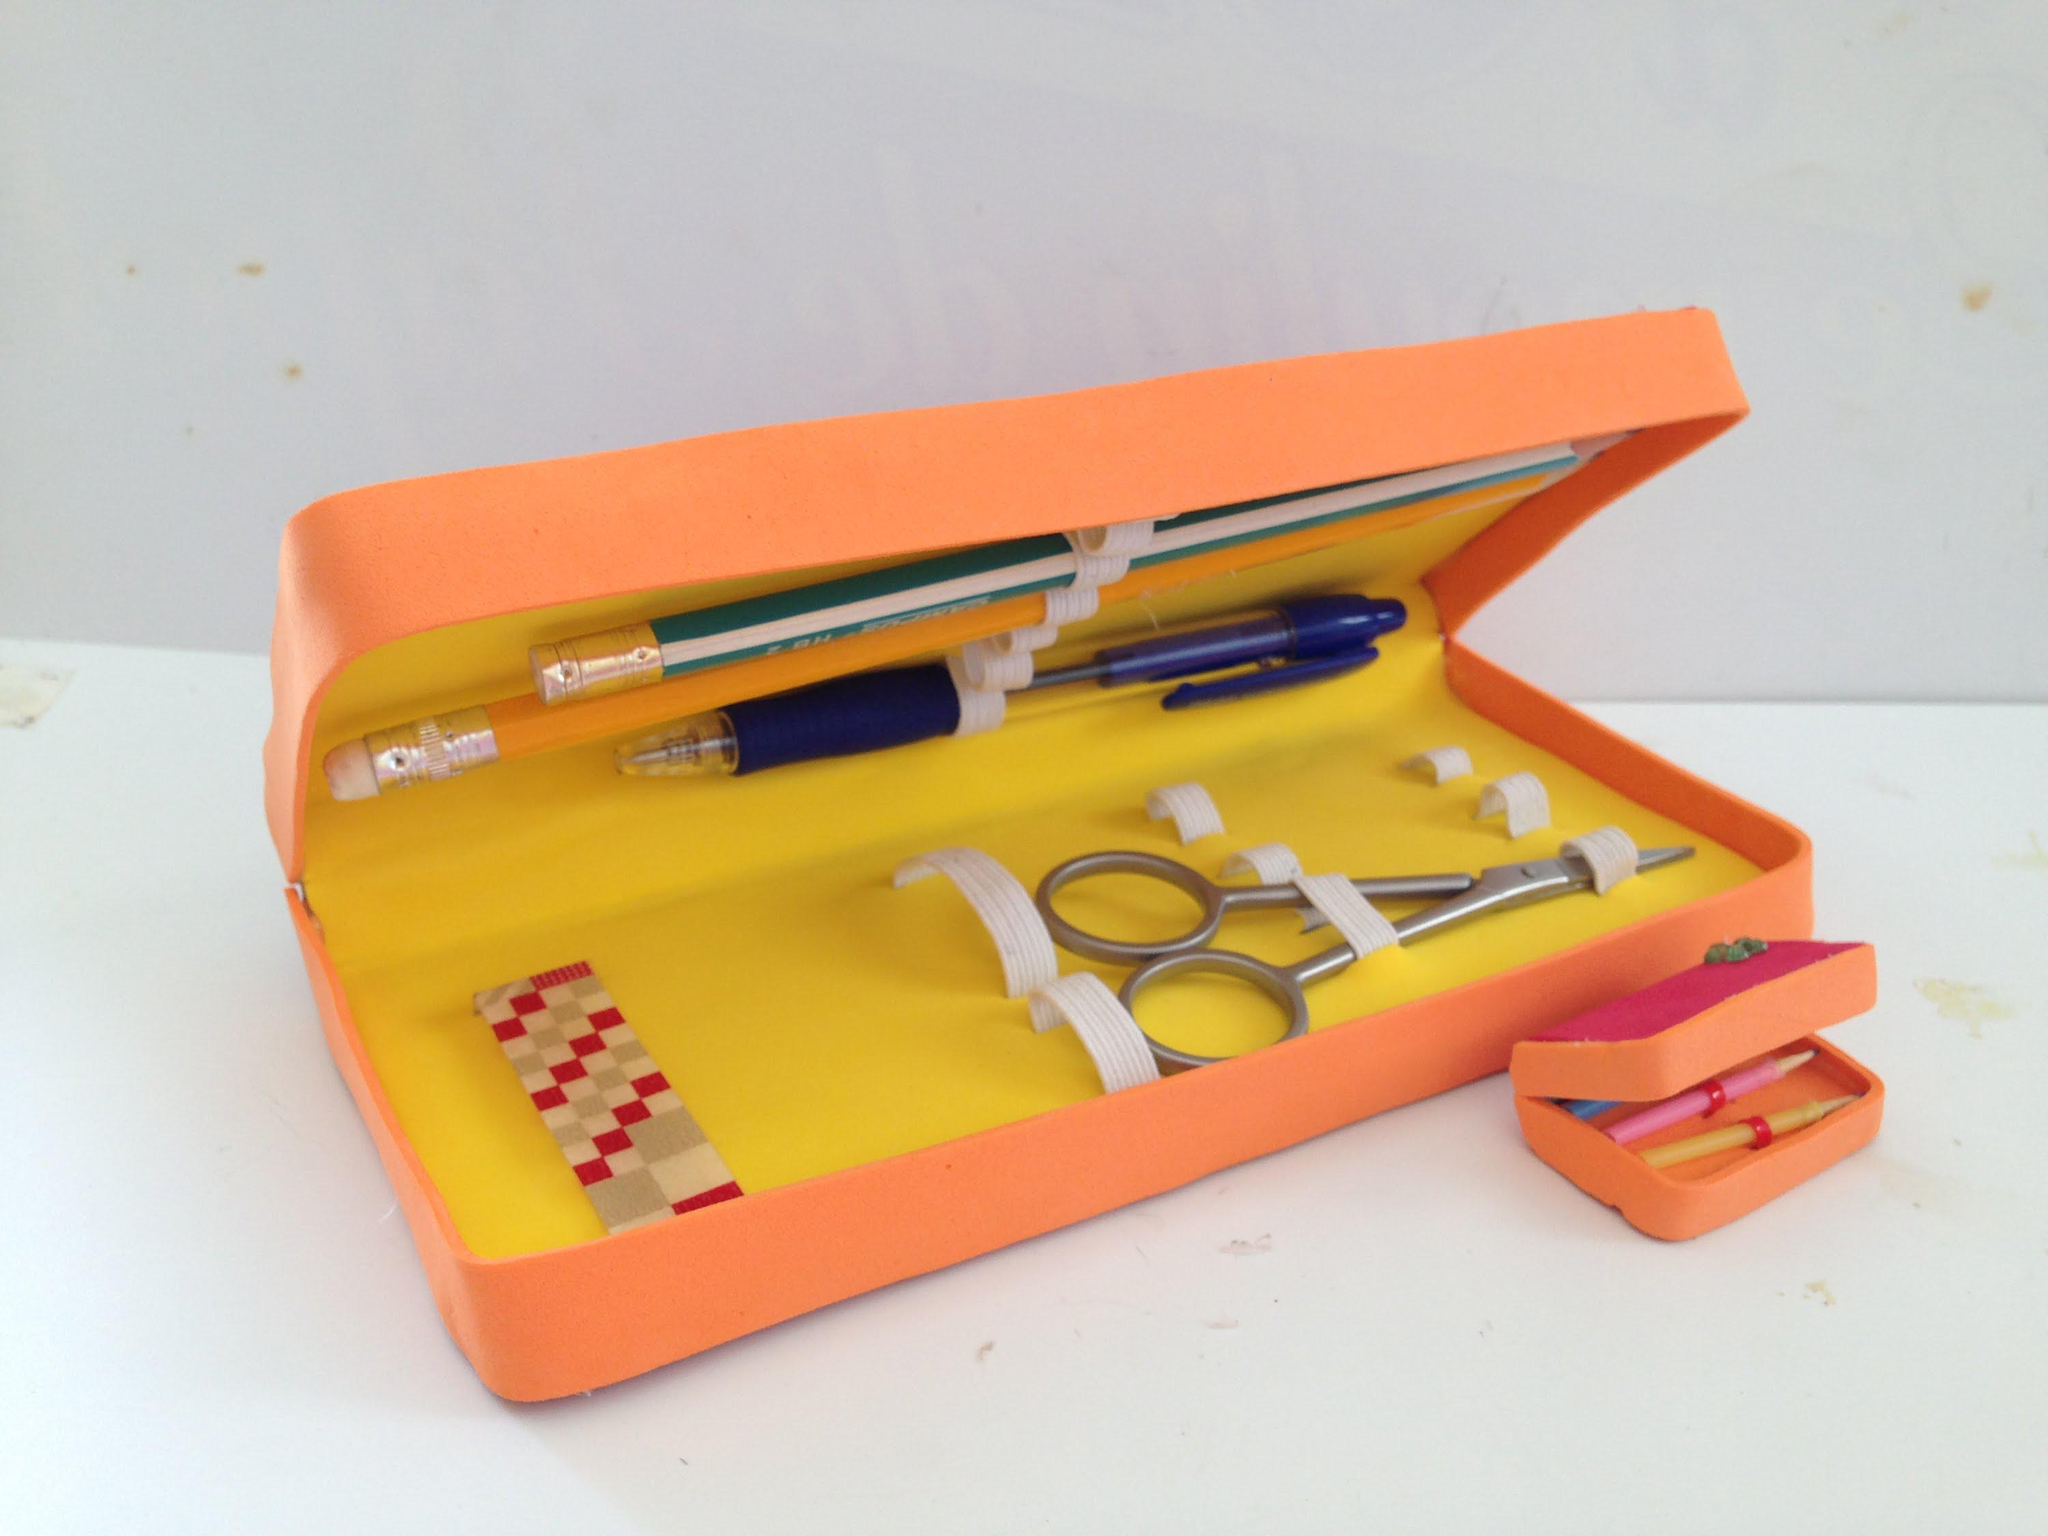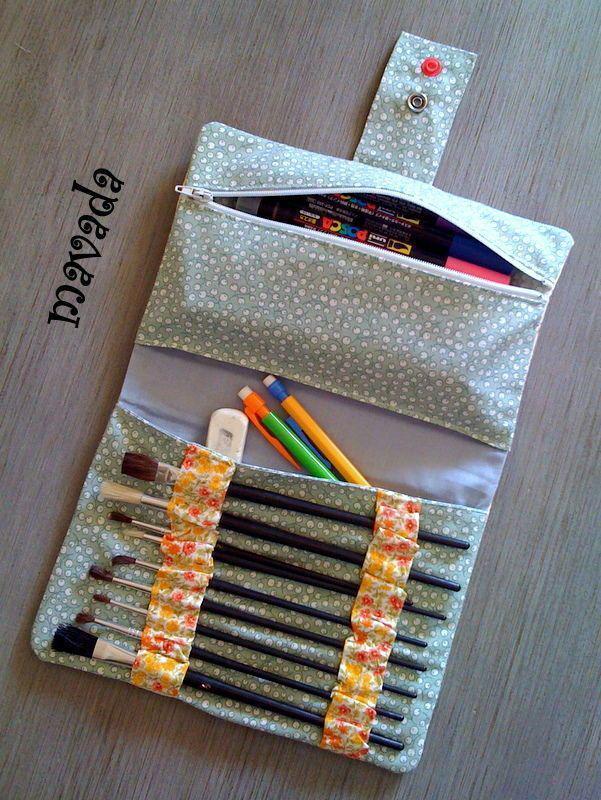The first image is the image on the left, the second image is the image on the right. Analyze the images presented: Is the assertion "There is a zipper in the image on the right." valid? Answer yes or no. Yes. 